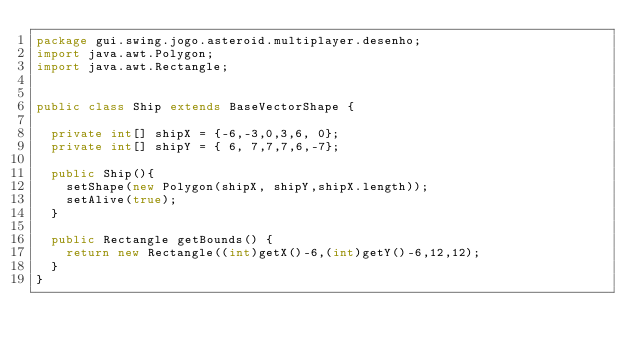Convert code to text. <code><loc_0><loc_0><loc_500><loc_500><_Java_>package gui.swing.jogo.asteroid.multiplayer.desenho;
import java.awt.Polygon;
import java.awt.Rectangle;


public class Ship extends BaseVectorShape {

	private int[] shipX = {-6,-3,0,3,6, 0};
	private int[] shipY = { 6, 7,7,7,6,-7};
	
	public Ship(){
		setShape(new Polygon(shipX, shipY,shipX.length));
		setAlive(true);
	}
	
	public Rectangle getBounds() {
		return new Rectangle((int)getX()-6,(int)getY()-6,12,12);
	}
}
</code> 